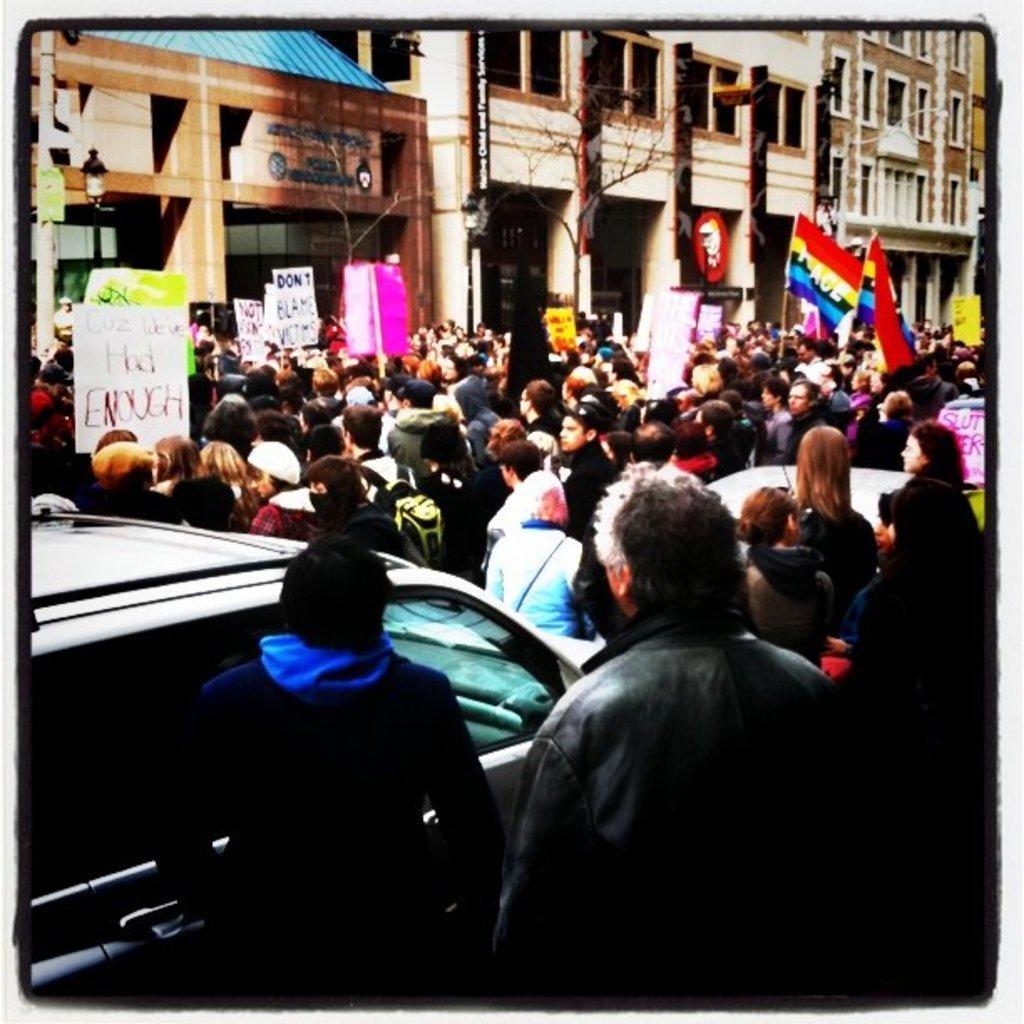How would you summarize this image in a sentence or two? In the image we can see there is a gathering of a people standing on the road and there are cars parked on the road. The people are holding flags, banners and hoardings in their hand. There are buildings and there are trees. 